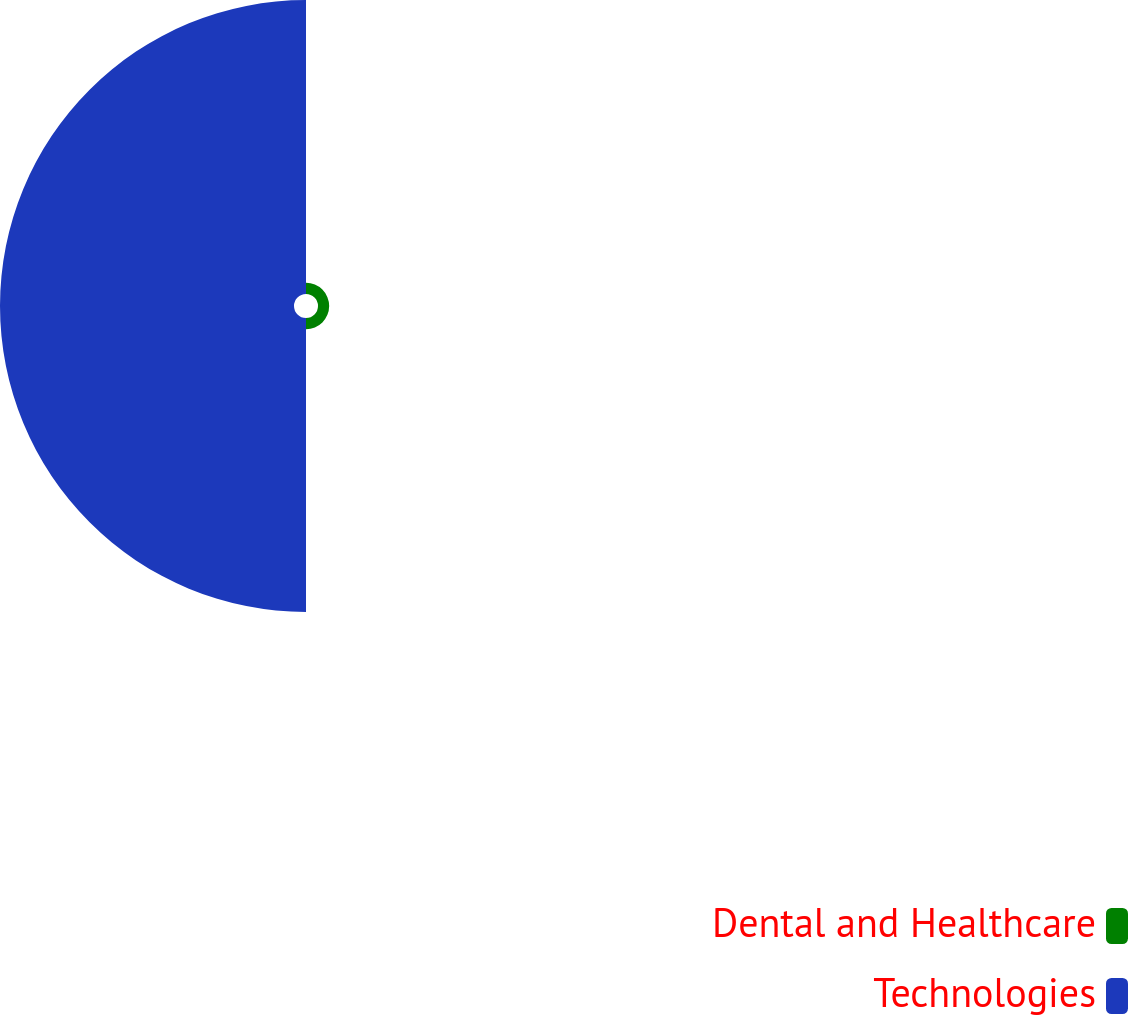<chart> <loc_0><loc_0><loc_500><loc_500><pie_chart><fcel>Dental and Healthcare<fcel>Technologies<nl><fcel>3.66%<fcel>96.34%<nl></chart> 